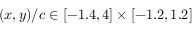Convert formula to latex. <formula><loc_0><loc_0><loc_500><loc_500>( x , y ) / c \in [ - 1 . 4 , 4 ] \times [ - 1 . 2 , 1 . 2 ]</formula> 